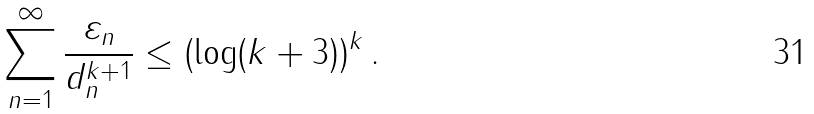Convert formula to latex. <formula><loc_0><loc_0><loc_500><loc_500>\sum _ { n = 1 } ^ { \infty } \frac { \varepsilon _ { n } } { d _ { n } ^ { k + 1 } } \leq ( \log ( k + 3 ) ) ^ { k } \, .</formula> 